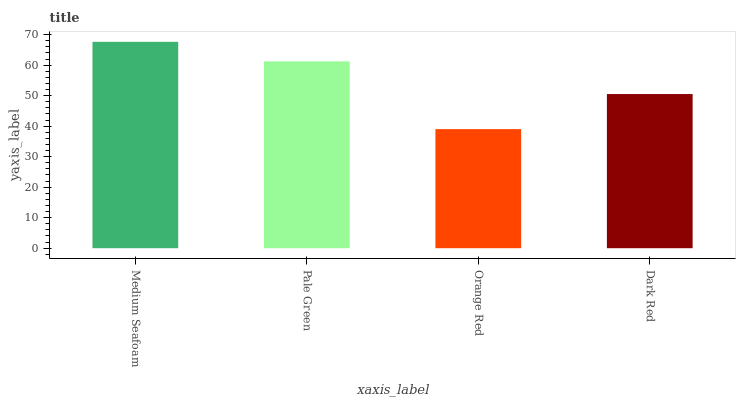Is Orange Red the minimum?
Answer yes or no. Yes. Is Medium Seafoam the maximum?
Answer yes or no. Yes. Is Pale Green the minimum?
Answer yes or no. No. Is Pale Green the maximum?
Answer yes or no. No. Is Medium Seafoam greater than Pale Green?
Answer yes or no. Yes. Is Pale Green less than Medium Seafoam?
Answer yes or no. Yes. Is Pale Green greater than Medium Seafoam?
Answer yes or no. No. Is Medium Seafoam less than Pale Green?
Answer yes or no. No. Is Pale Green the high median?
Answer yes or no. Yes. Is Dark Red the low median?
Answer yes or no. Yes. Is Medium Seafoam the high median?
Answer yes or no. No. Is Medium Seafoam the low median?
Answer yes or no. No. 